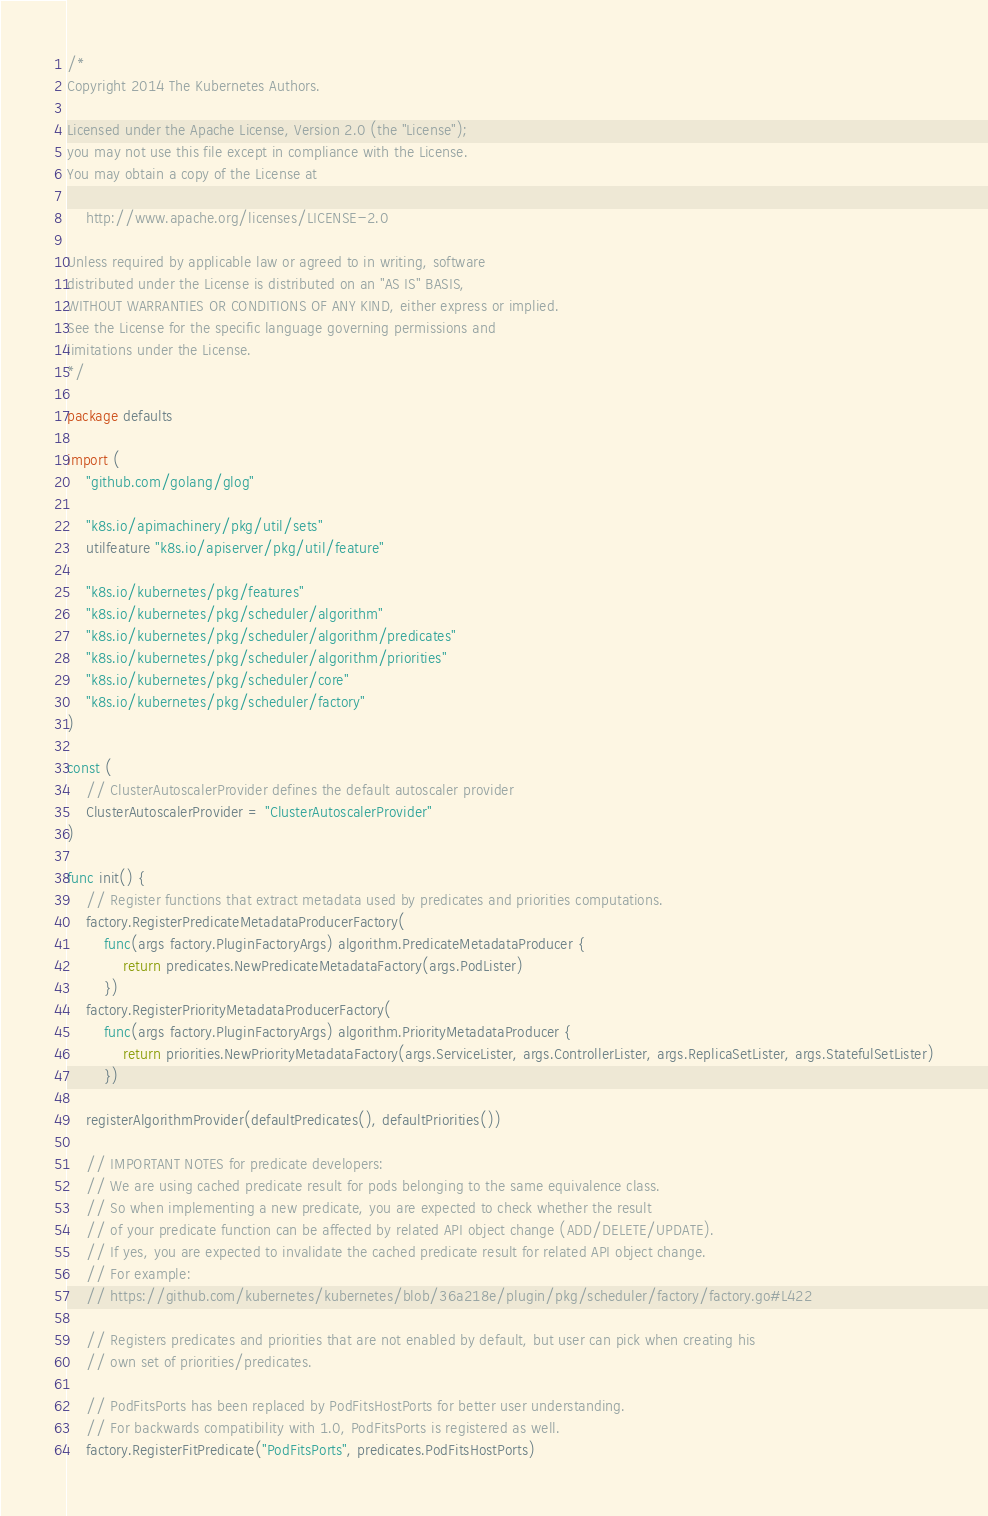Convert code to text. <code><loc_0><loc_0><loc_500><loc_500><_Go_>/*
Copyright 2014 The Kubernetes Authors.

Licensed under the Apache License, Version 2.0 (the "License");
you may not use this file except in compliance with the License.
You may obtain a copy of the License at

    http://www.apache.org/licenses/LICENSE-2.0

Unless required by applicable law or agreed to in writing, software
distributed under the License is distributed on an "AS IS" BASIS,
WITHOUT WARRANTIES OR CONDITIONS OF ANY KIND, either express or implied.
See the License for the specific language governing permissions and
limitations under the License.
*/

package defaults

import (
	"github.com/golang/glog"

	"k8s.io/apimachinery/pkg/util/sets"
	utilfeature "k8s.io/apiserver/pkg/util/feature"

	"k8s.io/kubernetes/pkg/features"
	"k8s.io/kubernetes/pkg/scheduler/algorithm"
	"k8s.io/kubernetes/pkg/scheduler/algorithm/predicates"
	"k8s.io/kubernetes/pkg/scheduler/algorithm/priorities"
	"k8s.io/kubernetes/pkg/scheduler/core"
	"k8s.io/kubernetes/pkg/scheduler/factory"
)

const (
	// ClusterAutoscalerProvider defines the default autoscaler provider
	ClusterAutoscalerProvider = "ClusterAutoscalerProvider"
)

func init() {
	// Register functions that extract metadata used by predicates and priorities computations.
	factory.RegisterPredicateMetadataProducerFactory(
		func(args factory.PluginFactoryArgs) algorithm.PredicateMetadataProducer {
			return predicates.NewPredicateMetadataFactory(args.PodLister)
		})
	factory.RegisterPriorityMetadataProducerFactory(
		func(args factory.PluginFactoryArgs) algorithm.PriorityMetadataProducer {
			return priorities.NewPriorityMetadataFactory(args.ServiceLister, args.ControllerLister, args.ReplicaSetLister, args.StatefulSetLister)
		})

	registerAlgorithmProvider(defaultPredicates(), defaultPriorities())

	// IMPORTANT NOTES for predicate developers:
	// We are using cached predicate result for pods belonging to the same equivalence class.
	// So when implementing a new predicate, you are expected to check whether the result
	// of your predicate function can be affected by related API object change (ADD/DELETE/UPDATE).
	// If yes, you are expected to invalidate the cached predicate result for related API object change.
	// For example:
	// https://github.com/kubernetes/kubernetes/blob/36a218e/plugin/pkg/scheduler/factory/factory.go#L422

	// Registers predicates and priorities that are not enabled by default, but user can pick when creating his
	// own set of priorities/predicates.

	// PodFitsPorts has been replaced by PodFitsHostPorts for better user understanding.
	// For backwards compatibility with 1.0, PodFitsPorts is registered as well.
	factory.RegisterFitPredicate("PodFitsPorts", predicates.PodFitsHostPorts)</code> 